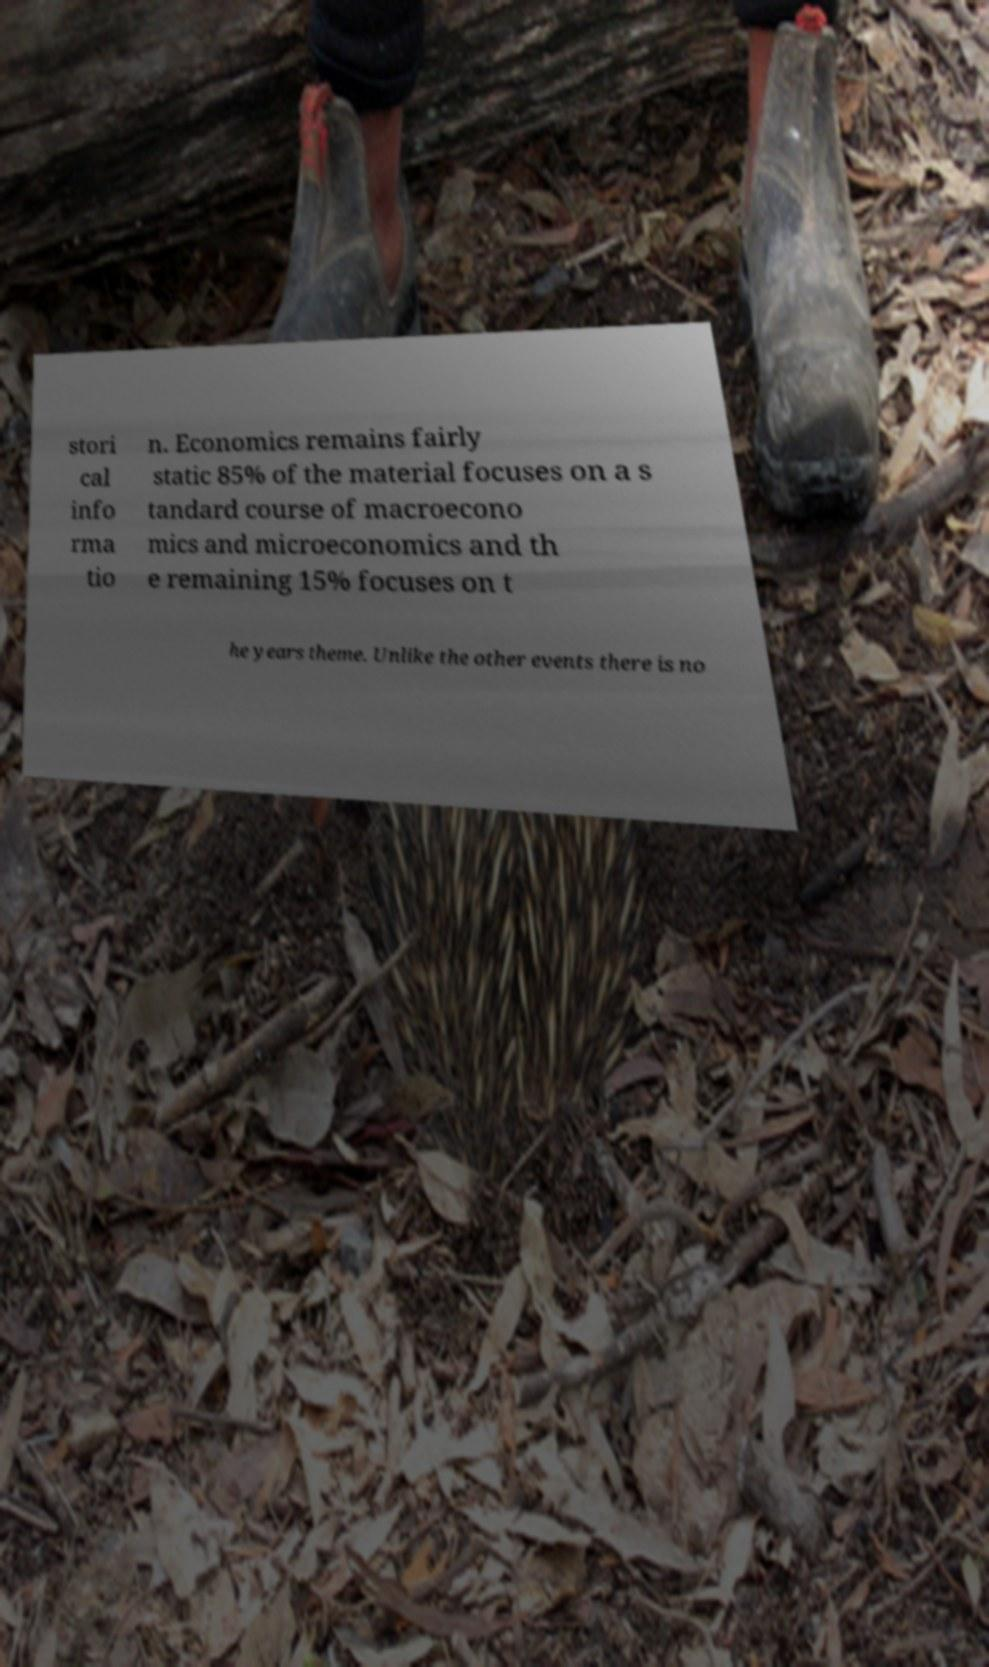I need the written content from this picture converted into text. Can you do that? stori cal info rma tio n. Economics remains fairly static 85% of the material focuses on a s tandard course of macroecono mics and microeconomics and th e remaining 15% focuses on t he years theme. Unlike the other events there is no 